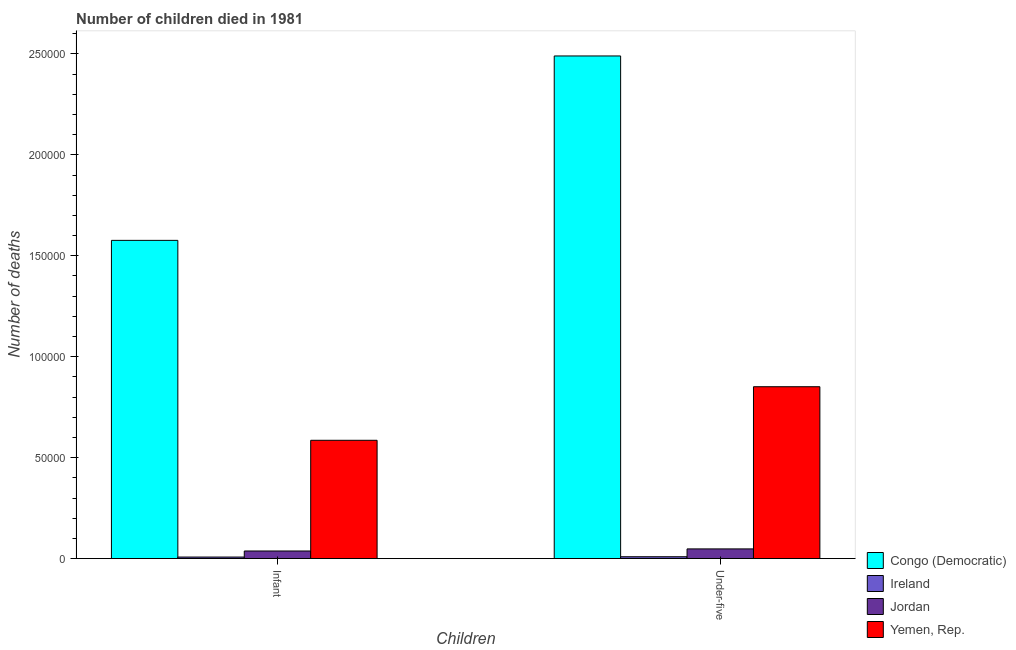How many different coloured bars are there?
Keep it short and to the point. 4. How many groups of bars are there?
Give a very brief answer. 2. Are the number of bars per tick equal to the number of legend labels?
Offer a terse response. Yes. Are the number of bars on each tick of the X-axis equal?
Your response must be concise. Yes. How many bars are there on the 2nd tick from the right?
Your answer should be very brief. 4. What is the label of the 1st group of bars from the left?
Give a very brief answer. Infant. What is the number of infant deaths in Yemen, Rep.?
Your answer should be compact. 5.86e+04. Across all countries, what is the maximum number of infant deaths?
Your response must be concise. 1.58e+05. Across all countries, what is the minimum number of under-five deaths?
Offer a very short reply. 905. In which country was the number of infant deaths maximum?
Your response must be concise. Congo (Democratic). In which country was the number of infant deaths minimum?
Make the answer very short. Ireland. What is the total number of infant deaths in the graph?
Make the answer very short. 2.21e+05. What is the difference between the number of under-five deaths in Ireland and that in Jordan?
Your response must be concise. -3884. What is the difference between the number of under-five deaths in Jordan and the number of infant deaths in Congo (Democratic)?
Keep it short and to the point. -1.53e+05. What is the average number of infant deaths per country?
Offer a very short reply. 5.52e+04. What is the difference between the number of under-five deaths and number of infant deaths in Yemen, Rep.?
Provide a succinct answer. 2.65e+04. What is the ratio of the number of infant deaths in Congo (Democratic) to that in Ireland?
Offer a very short reply. 209.64. Is the number of under-five deaths in Ireland less than that in Yemen, Rep.?
Ensure brevity in your answer.  Yes. What does the 2nd bar from the left in Under-five represents?
Your response must be concise. Ireland. What does the 2nd bar from the right in Infant represents?
Provide a short and direct response. Jordan. How many bars are there?
Ensure brevity in your answer.  8. Are all the bars in the graph horizontal?
Your answer should be very brief. No. How many countries are there in the graph?
Your answer should be very brief. 4. What is the difference between two consecutive major ticks on the Y-axis?
Offer a very short reply. 5.00e+04. Does the graph contain any zero values?
Make the answer very short. No. Does the graph contain grids?
Your response must be concise. No. Where does the legend appear in the graph?
Your answer should be compact. Bottom right. How are the legend labels stacked?
Provide a succinct answer. Vertical. What is the title of the graph?
Provide a succinct answer. Number of children died in 1981. Does "Oman" appear as one of the legend labels in the graph?
Your answer should be compact. No. What is the label or title of the X-axis?
Your answer should be very brief. Children. What is the label or title of the Y-axis?
Provide a short and direct response. Number of deaths. What is the Number of deaths in Congo (Democratic) in Infant?
Provide a succinct answer. 1.58e+05. What is the Number of deaths of Ireland in Infant?
Keep it short and to the point. 752. What is the Number of deaths of Jordan in Infant?
Your answer should be very brief. 3754. What is the Number of deaths of Yemen, Rep. in Infant?
Provide a short and direct response. 5.86e+04. What is the Number of deaths of Congo (Democratic) in Under-five?
Give a very brief answer. 2.49e+05. What is the Number of deaths of Ireland in Under-five?
Ensure brevity in your answer.  905. What is the Number of deaths in Jordan in Under-five?
Give a very brief answer. 4789. What is the Number of deaths of Yemen, Rep. in Under-five?
Offer a terse response. 8.51e+04. Across all Children, what is the maximum Number of deaths of Congo (Democratic)?
Offer a very short reply. 2.49e+05. Across all Children, what is the maximum Number of deaths of Ireland?
Provide a short and direct response. 905. Across all Children, what is the maximum Number of deaths in Jordan?
Your answer should be compact. 4789. Across all Children, what is the maximum Number of deaths in Yemen, Rep.?
Keep it short and to the point. 8.51e+04. Across all Children, what is the minimum Number of deaths in Congo (Democratic)?
Keep it short and to the point. 1.58e+05. Across all Children, what is the minimum Number of deaths in Ireland?
Keep it short and to the point. 752. Across all Children, what is the minimum Number of deaths of Jordan?
Offer a terse response. 3754. Across all Children, what is the minimum Number of deaths of Yemen, Rep.?
Make the answer very short. 5.86e+04. What is the total Number of deaths of Congo (Democratic) in the graph?
Your answer should be very brief. 4.07e+05. What is the total Number of deaths in Ireland in the graph?
Your answer should be very brief. 1657. What is the total Number of deaths of Jordan in the graph?
Offer a terse response. 8543. What is the total Number of deaths in Yemen, Rep. in the graph?
Your response must be concise. 1.44e+05. What is the difference between the Number of deaths in Congo (Democratic) in Infant and that in Under-five?
Make the answer very short. -9.14e+04. What is the difference between the Number of deaths of Ireland in Infant and that in Under-five?
Ensure brevity in your answer.  -153. What is the difference between the Number of deaths of Jordan in Infant and that in Under-five?
Make the answer very short. -1035. What is the difference between the Number of deaths in Yemen, Rep. in Infant and that in Under-five?
Give a very brief answer. -2.65e+04. What is the difference between the Number of deaths of Congo (Democratic) in Infant and the Number of deaths of Ireland in Under-five?
Offer a very short reply. 1.57e+05. What is the difference between the Number of deaths of Congo (Democratic) in Infant and the Number of deaths of Jordan in Under-five?
Your answer should be compact. 1.53e+05. What is the difference between the Number of deaths in Congo (Democratic) in Infant and the Number of deaths in Yemen, Rep. in Under-five?
Offer a terse response. 7.25e+04. What is the difference between the Number of deaths in Ireland in Infant and the Number of deaths in Jordan in Under-five?
Ensure brevity in your answer.  -4037. What is the difference between the Number of deaths of Ireland in Infant and the Number of deaths of Yemen, Rep. in Under-five?
Your answer should be compact. -8.44e+04. What is the difference between the Number of deaths of Jordan in Infant and the Number of deaths of Yemen, Rep. in Under-five?
Make the answer very short. -8.14e+04. What is the average Number of deaths of Congo (Democratic) per Children?
Provide a short and direct response. 2.03e+05. What is the average Number of deaths in Ireland per Children?
Offer a very short reply. 828.5. What is the average Number of deaths of Jordan per Children?
Offer a very short reply. 4271.5. What is the average Number of deaths of Yemen, Rep. per Children?
Provide a short and direct response. 7.19e+04. What is the difference between the Number of deaths of Congo (Democratic) and Number of deaths of Ireland in Infant?
Your response must be concise. 1.57e+05. What is the difference between the Number of deaths of Congo (Democratic) and Number of deaths of Jordan in Infant?
Provide a short and direct response. 1.54e+05. What is the difference between the Number of deaths in Congo (Democratic) and Number of deaths in Yemen, Rep. in Infant?
Provide a succinct answer. 9.91e+04. What is the difference between the Number of deaths in Ireland and Number of deaths in Jordan in Infant?
Ensure brevity in your answer.  -3002. What is the difference between the Number of deaths in Ireland and Number of deaths in Yemen, Rep. in Infant?
Keep it short and to the point. -5.78e+04. What is the difference between the Number of deaths in Jordan and Number of deaths in Yemen, Rep. in Infant?
Provide a succinct answer. -5.48e+04. What is the difference between the Number of deaths in Congo (Democratic) and Number of deaths in Ireland in Under-five?
Offer a terse response. 2.48e+05. What is the difference between the Number of deaths in Congo (Democratic) and Number of deaths in Jordan in Under-five?
Give a very brief answer. 2.44e+05. What is the difference between the Number of deaths in Congo (Democratic) and Number of deaths in Yemen, Rep. in Under-five?
Ensure brevity in your answer.  1.64e+05. What is the difference between the Number of deaths of Ireland and Number of deaths of Jordan in Under-five?
Provide a succinct answer. -3884. What is the difference between the Number of deaths in Ireland and Number of deaths in Yemen, Rep. in Under-five?
Your response must be concise. -8.42e+04. What is the difference between the Number of deaths in Jordan and Number of deaths in Yemen, Rep. in Under-five?
Your answer should be very brief. -8.04e+04. What is the ratio of the Number of deaths of Congo (Democratic) in Infant to that in Under-five?
Make the answer very short. 0.63. What is the ratio of the Number of deaths of Ireland in Infant to that in Under-five?
Ensure brevity in your answer.  0.83. What is the ratio of the Number of deaths in Jordan in Infant to that in Under-five?
Make the answer very short. 0.78. What is the ratio of the Number of deaths of Yemen, Rep. in Infant to that in Under-five?
Ensure brevity in your answer.  0.69. What is the difference between the highest and the second highest Number of deaths of Congo (Democratic)?
Ensure brevity in your answer.  9.14e+04. What is the difference between the highest and the second highest Number of deaths in Ireland?
Keep it short and to the point. 153. What is the difference between the highest and the second highest Number of deaths in Jordan?
Your response must be concise. 1035. What is the difference between the highest and the second highest Number of deaths of Yemen, Rep.?
Provide a succinct answer. 2.65e+04. What is the difference between the highest and the lowest Number of deaths in Congo (Democratic)?
Give a very brief answer. 9.14e+04. What is the difference between the highest and the lowest Number of deaths of Ireland?
Your answer should be compact. 153. What is the difference between the highest and the lowest Number of deaths in Jordan?
Your answer should be very brief. 1035. What is the difference between the highest and the lowest Number of deaths of Yemen, Rep.?
Offer a terse response. 2.65e+04. 